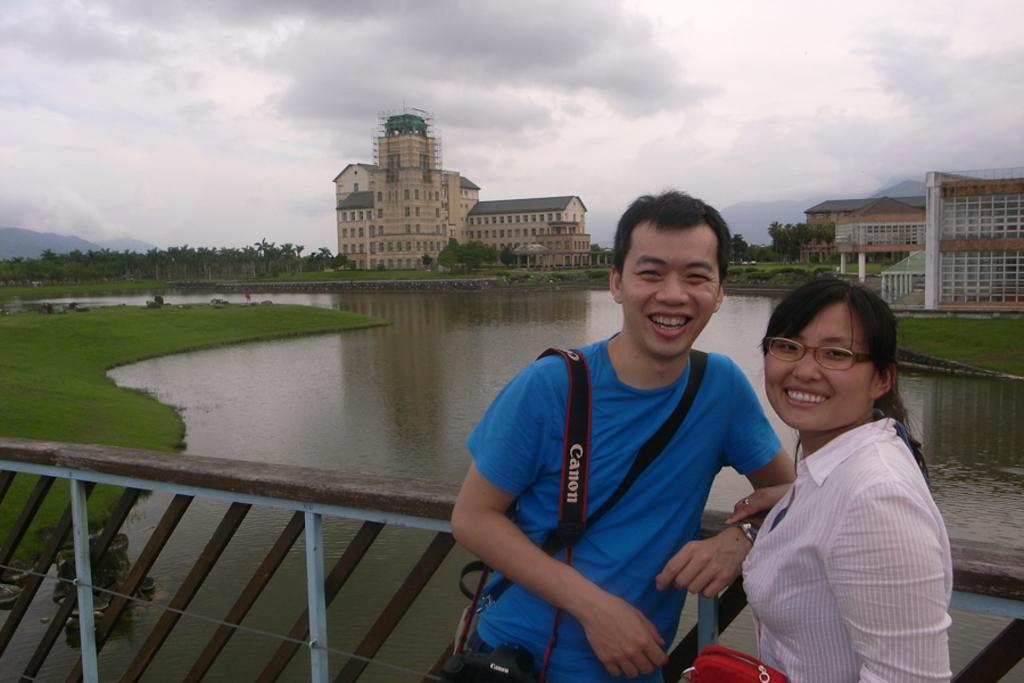<image>
Create a compact narrative representing the image presented. a man with a camera that has a canon strap 